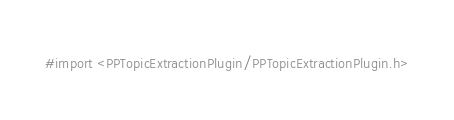<code> <loc_0><loc_0><loc_500><loc_500><_C_>#import <PPTopicExtractionPlugin/PPTopicExtractionPlugin.h>
</code> 